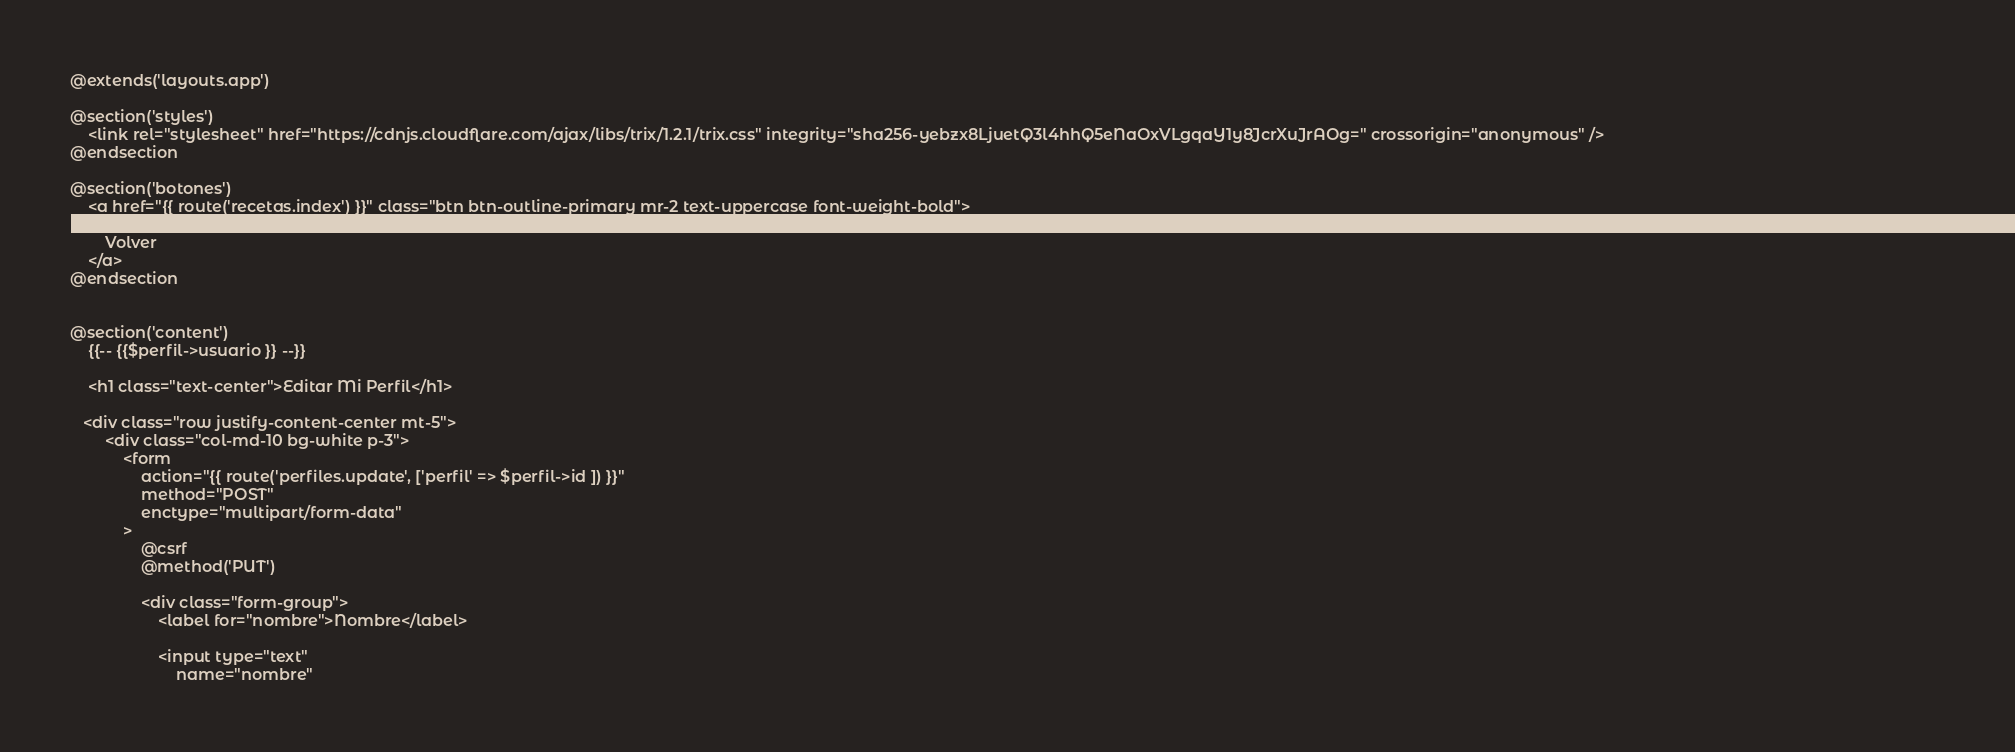<code> <loc_0><loc_0><loc_500><loc_500><_PHP_>@extends('layouts.app')

@section('styles')
    <link rel="stylesheet" href="https://cdnjs.cloudflare.com/ajax/libs/trix/1.2.1/trix.css" integrity="sha256-yebzx8LjuetQ3l4hhQ5eNaOxVLgqaY1y8JcrXuJrAOg=" crossorigin="anonymous" />
@endsection

@section('botones')
    <a href="{{ route('recetas.index') }}" class="btn btn-outline-primary mr-2 text-uppercase font-weight-bold">
        <svg class="icono" fill="none" stroke-linecap="round" stroke-linejoin="round" stroke-width="2" stroke="currentColor" viewBox="0 0 24 24"><path d="M11 15l-3-3m0 0l3-3m-3 3h8M3 12a9 9 0 1118 0 9 9 0 01-18 0z"></path></svg>
        Volver
    </a>
@endsection


@section('content')
    {{-- {{$perfil->usuario }} --}}

    <h1 class="text-center">Editar Mi Perfil</h1>

   <div class="row justify-content-center mt-5">
        <div class="col-md-10 bg-white p-3">
            <form
                action="{{ route('perfiles.update', ['perfil' => $perfil->id ]) }}"
                method="POST"
                enctype="multipart/form-data"
            >
                @csrf
                @method('PUT')

                <div class="form-group">
                    <label for="nombre">Nombre</label>

                    <input type="text"
                        name="nombre"</code> 